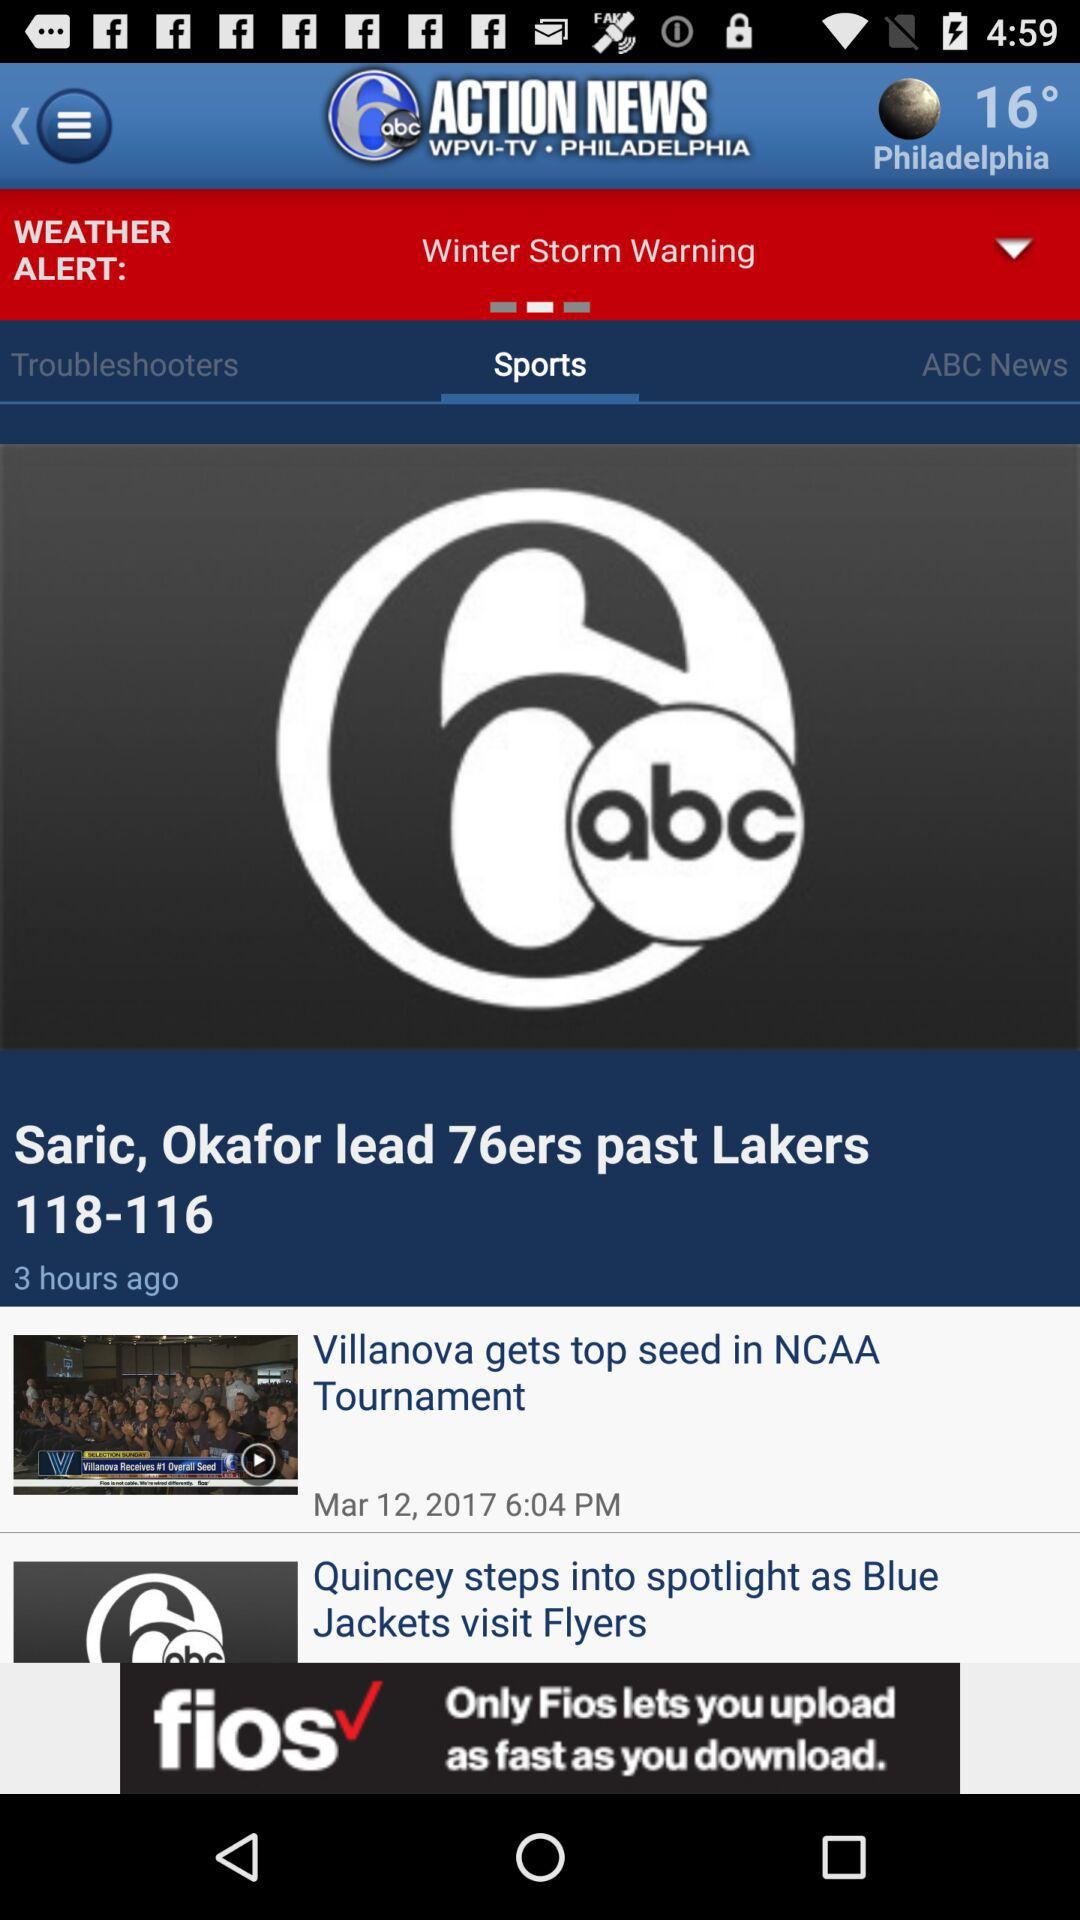What is the temperature? The temperature is 16°. 